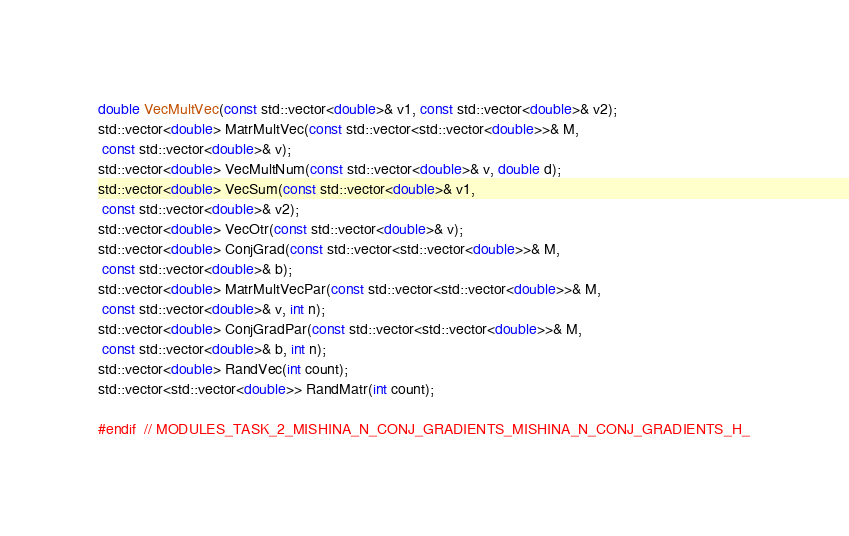<code> <loc_0><loc_0><loc_500><loc_500><_C_>double VecMultVec(const std::vector<double>& v1, const std::vector<double>& v2);
std::vector<double> MatrMultVec(const std::vector<std::vector<double>>& M,
 const std::vector<double>& v);
std::vector<double> VecMultNum(const std::vector<double>& v, double d);
std::vector<double> VecSum(const std::vector<double>& v1,
 const std::vector<double>& v2);
std::vector<double> VecOtr(const std::vector<double>& v);
std::vector<double> ConjGrad(const std::vector<std::vector<double>>& M,
 const std::vector<double>& b);
std::vector<double> MatrMultVecPar(const std::vector<std::vector<double>>& M,
 const std::vector<double>& v, int n);
std::vector<double> ConjGradPar(const std::vector<std::vector<double>>& M,
 const std::vector<double>& b, int n);
std::vector<double> RandVec(int count);
std::vector<std::vector<double>> RandMatr(int count);

#endif  // MODULES_TASK_2_MISHINA_N_CONJ_GRADIENTS_MISHINA_N_CONJ_GRADIENTS_H_
</code> 